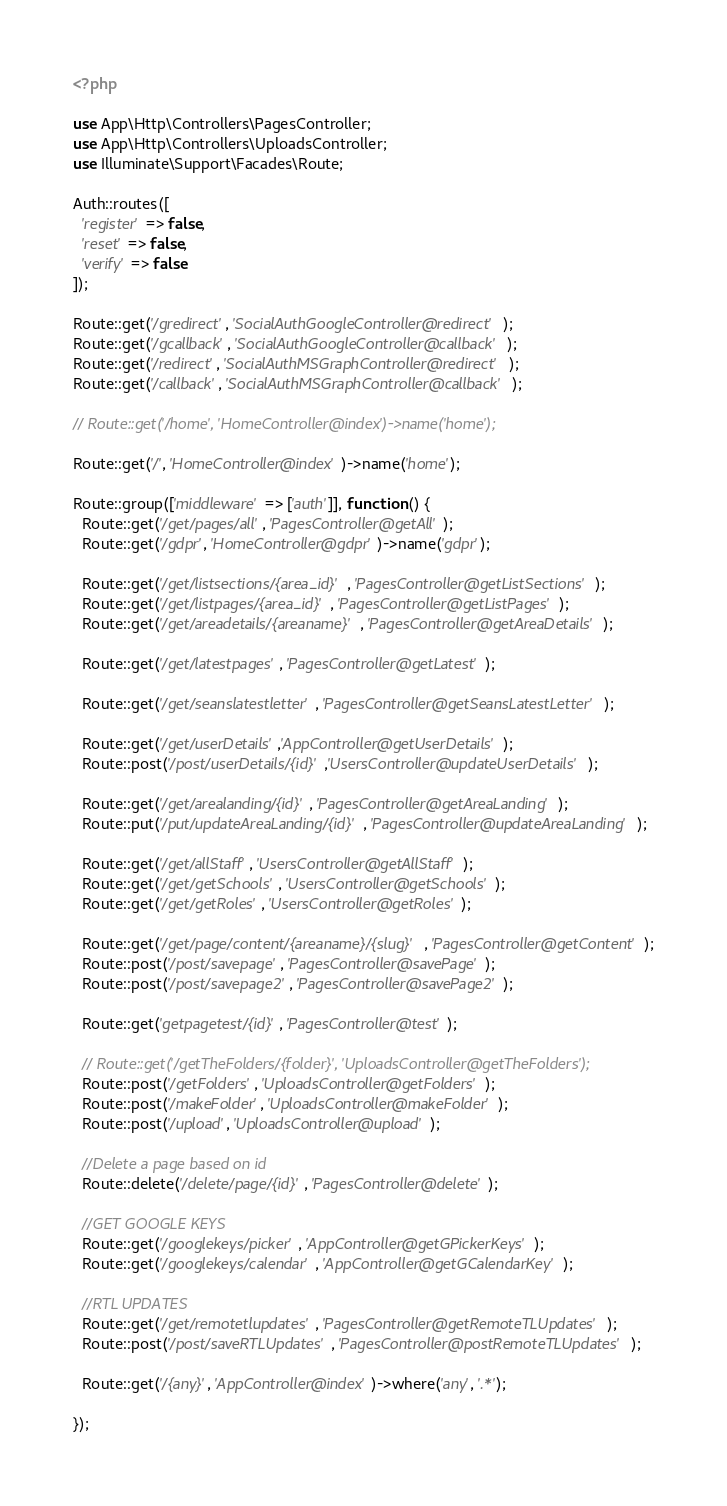Convert code to text. <code><loc_0><loc_0><loc_500><loc_500><_PHP_><?php

use App\Http\Controllers\PagesController;
use App\Http\Controllers\UploadsController;
use Illuminate\Support\Facades\Route;

Auth::routes([
  'register' => false,
  'reset' => false,
  'verify' => false
]);

Route::get('/gredirect', 'SocialAuthGoogleController@redirect');
Route::get('/gcallback', 'SocialAuthGoogleController@callback');
Route::get('/redirect', 'SocialAuthMSGraphController@redirect');
Route::get('/callback', 'SocialAuthMSGraphController@callback');

// Route::get('/home', 'HomeController@index')->name('home');

Route::get('/', 'HomeController@index')->name('home');

Route::group(['middleware' => ['auth']], function () {
  Route::get('/get/pages/all', 'PagesController@getAll');
  Route::get('/gdpr', 'HomeController@gdpr')->name('gdpr');

  Route::get('/get/listsections/{area_id}', 'PagesController@getListSections');
  Route::get('/get/listpages/{area_id}', 'PagesController@getListPages');
  Route::get('/get/areadetails/{areaname}', 'PagesController@getAreaDetails');

  Route::get('/get/latestpages', 'PagesController@getLatest');

  Route::get('/get/seanslatestletter', 'PagesController@getSeansLatestLetter');

  Route::get('/get/userDetails','AppController@getUserDetails');
  Route::post('/post/userDetails/{id}','UsersController@updateUserDetails');

  Route::get('/get/arealanding/{id}', 'PagesController@getAreaLanding');
  Route::put('/put/updateAreaLanding/{id}', 'PagesController@updateAreaLanding');

  Route::get('/get/allStaff', 'UsersController@getAllStaff');
  Route::get('/get/getSchools', 'UsersController@getSchools');
  Route::get('/get/getRoles', 'UsersController@getRoles');

  Route::get('/get/page/content/{areaname}/{slug}', 'PagesController@getContent');
  Route::post('/post/savepage', 'PagesController@savePage');
  Route::post('/post/savepage2', 'PagesController@savePage2');

  Route::get('getpagetest/{id}', 'PagesController@test');

  // Route::get('/getTheFolders/{folder}', 'UploadsController@getTheFolders');
  Route::post('/getFolders', 'UploadsController@getFolders');
  Route::post('/makeFolder', 'UploadsController@makeFolder');
  Route::post('/upload', 'UploadsController@upload');

  //Delete a page based on id
  Route::delete('/delete/page/{id}', 'PagesController@delete');

  //GET GOOGLE KEYS
  Route::get('/googlekeys/picker', 'AppController@getGPickerKeys');
  Route::get('/googlekeys/calendar', 'AppController@getGCalendarKey');

  //RTL UPDATES
  Route::get('/get/remotetlupdates', 'PagesController@getRemoteTLUpdates');
  Route::post('/post/saveRTLUpdates', 'PagesController@postRemoteTLUpdates');

  Route::get('/{any}', 'AppController@index')->where('any', '.*');

});


</code> 